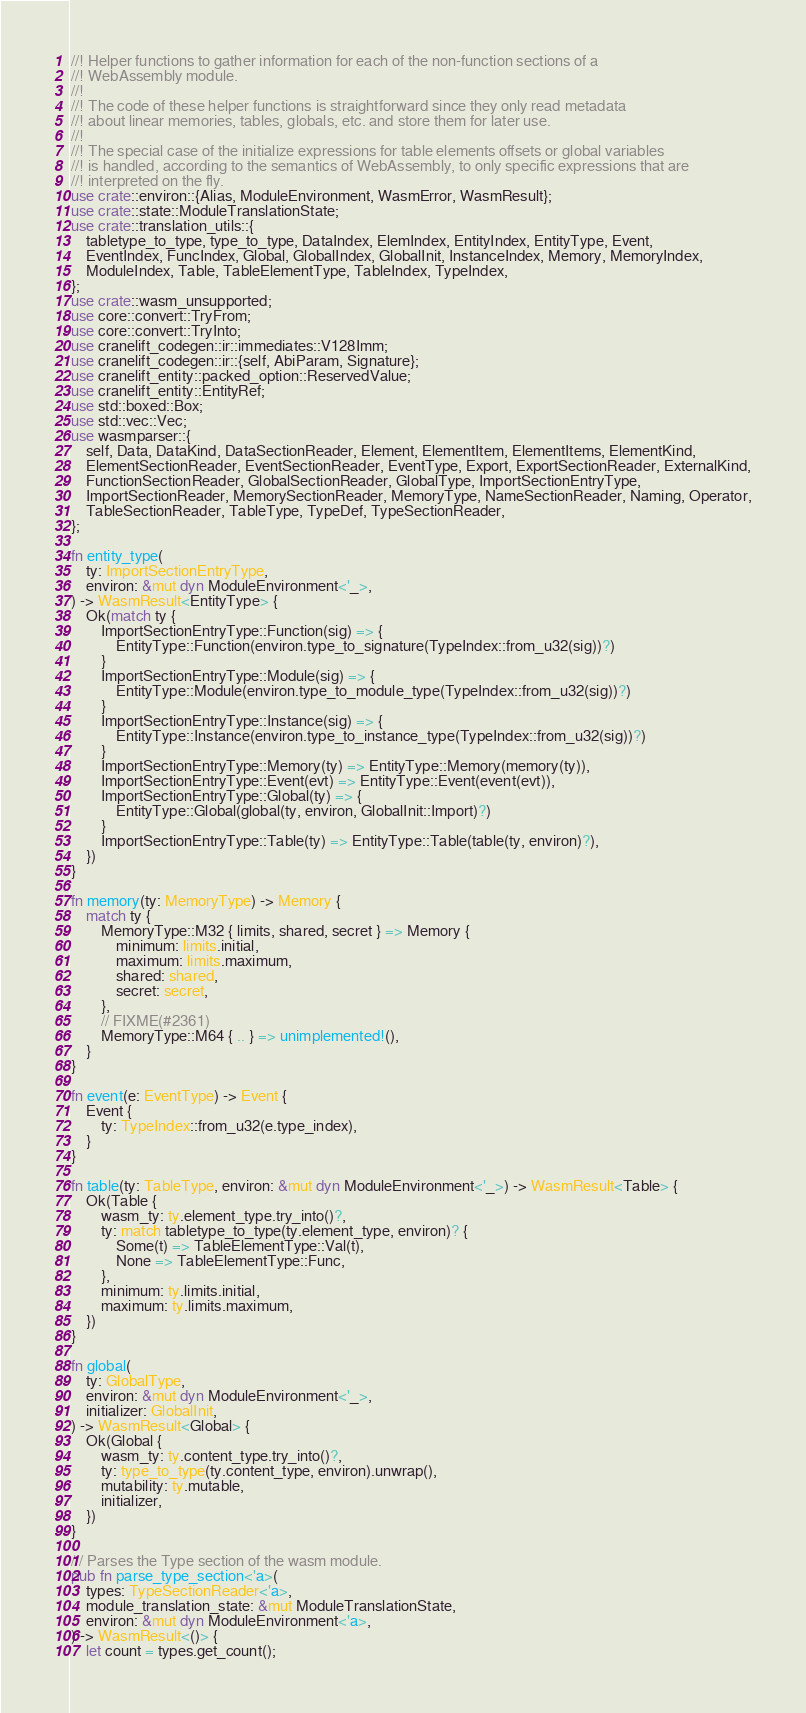Convert code to text. <code><loc_0><loc_0><loc_500><loc_500><_Rust_>//! Helper functions to gather information for each of the non-function sections of a
//! WebAssembly module.
//!
//! The code of these helper functions is straightforward since they only read metadata
//! about linear memories, tables, globals, etc. and store them for later use.
//!
//! The special case of the initialize expressions for table elements offsets or global variables
//! is handled, according to the semantics of WebAssembly, to only specific expressions that are
//! interpreted on the fly.
use crate::environ::{Alias, ModuleEnvironment, WasmError, WasmResult};
use crate::state::ModuleTranslationState;
use crate::translation_utils::{
    tabletype_to_type, type_to_type, DataIndex, ElemIndex, EntityIndex, EntityType, Event,
    EventIndex, FuncIndex, Global, GlobalIndex, GlobalInit, InstanceIndex, Memory, MemoryIndex,
    ModuleIndex, Table, TableElementType, TableIndex, TypeIndex,
};
use crate::wasm_unsupported;
use core::convert::TryFrom;
use core::convert::TryInto;
use cranelift_codegen::ir::immediates::V128Imm;
use cranelift_codegen::ir::{self, AbiParam, Signature};
use cranelift_entity::packed_option::ReservedValue;
use cranelift_entity::EntityRef;
use std::boxed::Box;
use std::vec::Vec;
use wasmparser::{
    self, Data, DataKind, DataSectionReader, Element, ElementItem, ElementItems, ElementKind,
    ElementSectionReader, EventSectionReader, EventType, Export, ExportSectionReader, ExternalKind,
    FunctionSectionReader, GlobalSectionReader, GlobalType, ImportSectionEntryType,
    ImportSectionReader, MemorySectionReader, MemoryType, NameSectionReader, Naming, Operator,
    TableSectionReader, TableType, TypeDef, TypeSectionReader,
};

fn entity_type(
    ty: ImportSectionEntryType,
    environ: &mut dyn ModuleEnvironment<'_>,
) -> WasmResult<EntityType> {
    Ok(match ty {
        ImportSectionEntryType::Function(sig) => {
            EntityType::Function(environ.type_to_signature(TypeIndex::from_u32(sig))?)
        }
        ImportSectionEntryType::Module(sig) => {
            EntityType::Module(environ.type_to_module_type(TypeIndex::from_u32(sig))?)
        }
        ImportSectionEntryType::Instance(sig) => {
            EntityType::Instance(environ.type_to_instance_type(TypeIndex::from_u32(sig))?)
        }
        ImportSectionEntryType::Memory(ty) => EntityType::Memory(memory(ty)),
        ImportSectionEntryType::Event(evt) => EntityType::Event(event(evt)),
        ImportSectionEntryType::Global(ty) => {
            EntityType::Global(global(ty, environ, GlobalInit::Import)?)
        }
        ImportSectionEntryType::Table(ty) => EntityType::Table(table(ty, environ)?),
    })
}

fn memory(ty: MemoryType) -> Memory {
    match ty {
        MemoryType::M32 { limits, shared, secret } => Memory {
            minimum: limits.initial,
            maximum: limits.maximum,
            shared: shared,
            secret: secret,
        },
        // FIXME(#2361)
        MemoryType::M64 { .. } => unimplemented!(),
    }
}

fn event(e: EventType) -> Event {
    Event {
        ty: TypeIndex::from_u32(e.type_index),
    }
}

fn table(ty: TableType, environ: &mut dyn ModuleEnvironment<'_>) -> WasmResult<Table> {
    Ok(Table {
        wasm_ty: ty.element_type.try_into()?,
        ty: match tabletype_to_type(ty.element_type, environ)? {
            Some(t) => TableElementType::Val(t),
            None => TableElementType::Func,
        },
        minimum: ty.limits.initial,
        maximum: ty.limits.maximum,
    })
}

fn global(
    ty: GlobalType,
    environ: &mut dyn ModuleEnvironment<'_>,
    initializer: GlobalInit,
) -> WasmResult<Global> {
    Ok(Global {
        wasm_ty: ty.content_type.try_into()?,
        ty: type_to_type(ty.content_type, environ).unwrap(),
        mutability: ty.mutable,
        initializer,
    })
}

/// Parses the Type section of the wasm module.
pub fn parse_type_section<'a>(
    types: TypeSectionReader<'a>,
    module_translation_state: &mut ModuleTranslationState,
    environ: &mut dyn ModuleEnvironment<'a>,
) -> WasmResult<()> {
    let count = types.get_count();</code> 